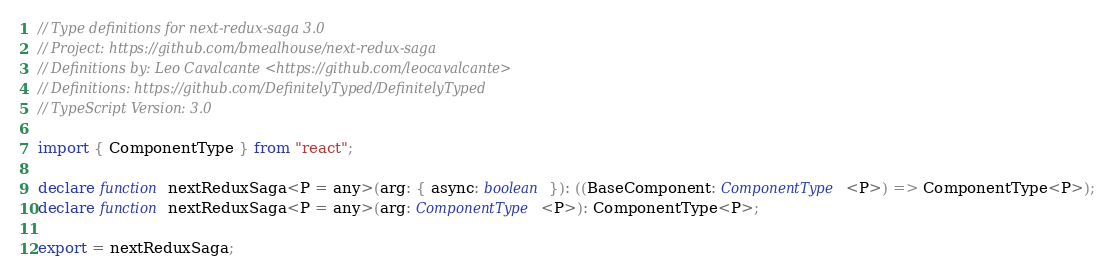Convert code to text. <code><loc_0><loc_0><loc_500><loc_500><_TypeScript_>// Type definitions for next-redux-saga 3.0
// Project: https://github.com/bmealhouse/next-redux-saga
// Definitions by: Leo Cavalcante <https://github.com/leocavalcante>
// Definitions: https://github.com/DefinitelyTyped/DefinitelyTyped
// TypeScript Version: 3.0

import { ComponentType } from "react";

declare function nextReduxSaga<P = any>(arg: { async: boolean }): ((BaseComponent: ComponentType<P>) => ComponentType<P>);
declare function nextReduxSaga<P = any>(arg: ComponentType<P>): ComponentType<P>;

export = nextReduxSaga;
</code> 